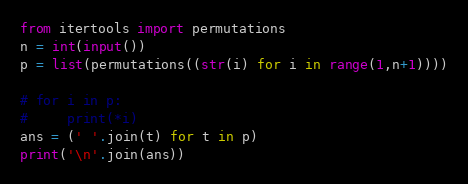<code> <loc_0><loc_0><loc_500><loc_500><_Python_>from itertools import permutations
n = int(input())
p = list(permutations((str(i) for i in range(1,n+1))))

# for i in p:
#     print(*i)
ans = (' '.join(t) for t in p)
print('\n'.join(ans))
</code> 